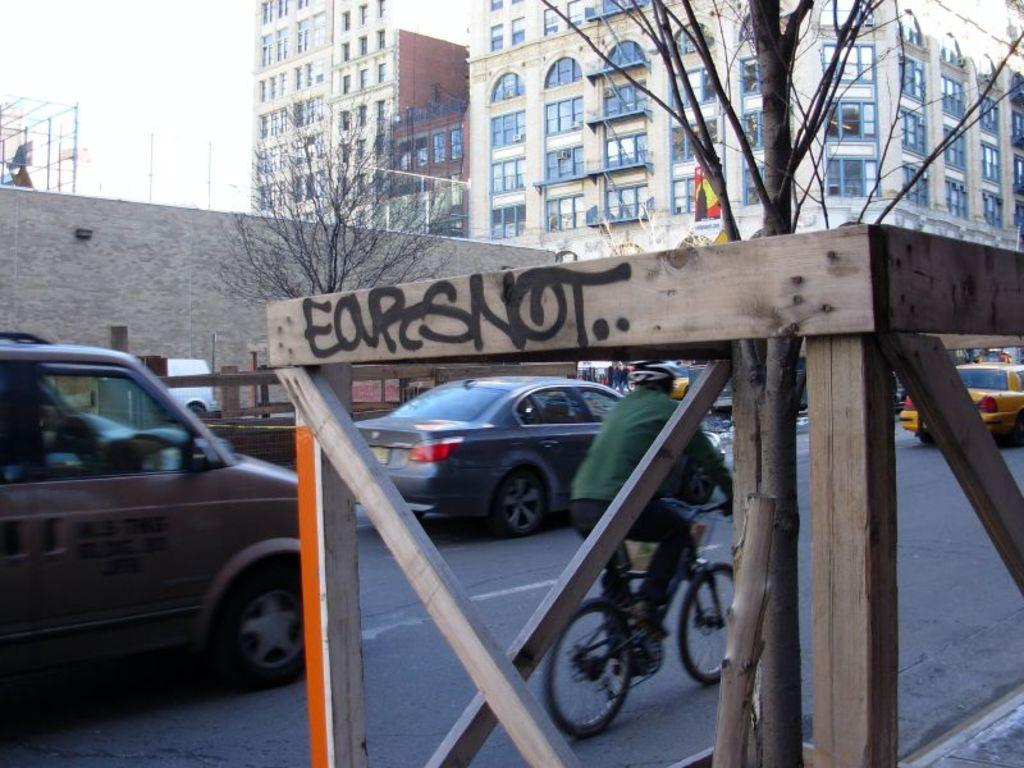What type of transportation can be seen on the road in the image? There are vehicles on the road in the image. What mode of transportation is the person using in the image? A person is riding a bicycle in the image. What type of vegetation is visible in the image? There are trees visible in the image. What type of structures can be seen in the image? There are buildings with windows in the image. What is the condition of the sky in the image? The sky is visible in the image and appears cloudy. Can you see any stick-wielding dinosaurs in the image? There are no dinosaurs present in the image, let alone ones wielding sticks. Is there a baby visible in the image? There is no baby present in the image. 